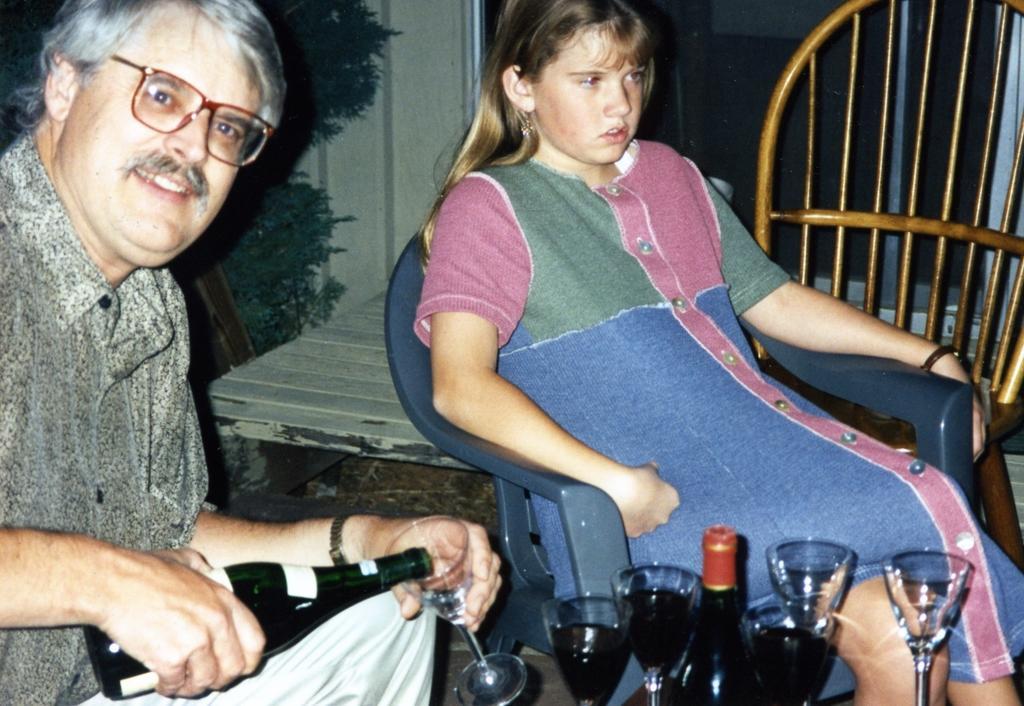Describe this image in one or two sentences. In the picture, there are total two people a kid and a man, a man is pouring some drink into the glass, beside that there are also few other drinks and a bottle,to the right side there is another chair, in the background there is a wall and beside that there is a tree,to the right side there is a window. 